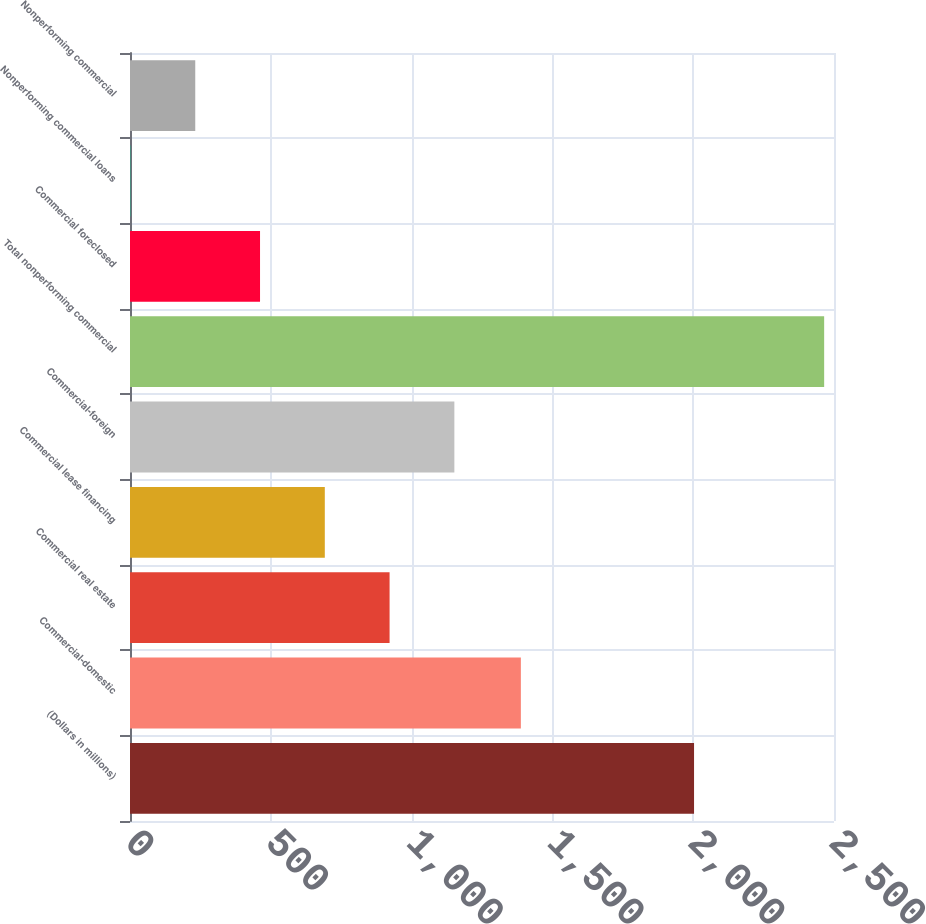Convert chart to OTSL. <chart><loc_0><loc_0><loc_500><loc_500><bar_chart><fcel>(Dollars in millions)<fcel>Commercial-domestic<fcel>Commercial real estate<fcel>Commercial lease financing<fcel>Commercial-foreign<fcel>Total nonperforming commercial<fcel>Commercial foreclosed<fcel>Nonperforming commercial loans<fcel>Nonperforming commercial<nl><fcel>2003<fcel>1388<fcel>921.82<fcel>691.79<fcel>1151.85<fcel>2465.03<fcel>461.76<fcel>1.7<fcel>231.73<nl></chart> 